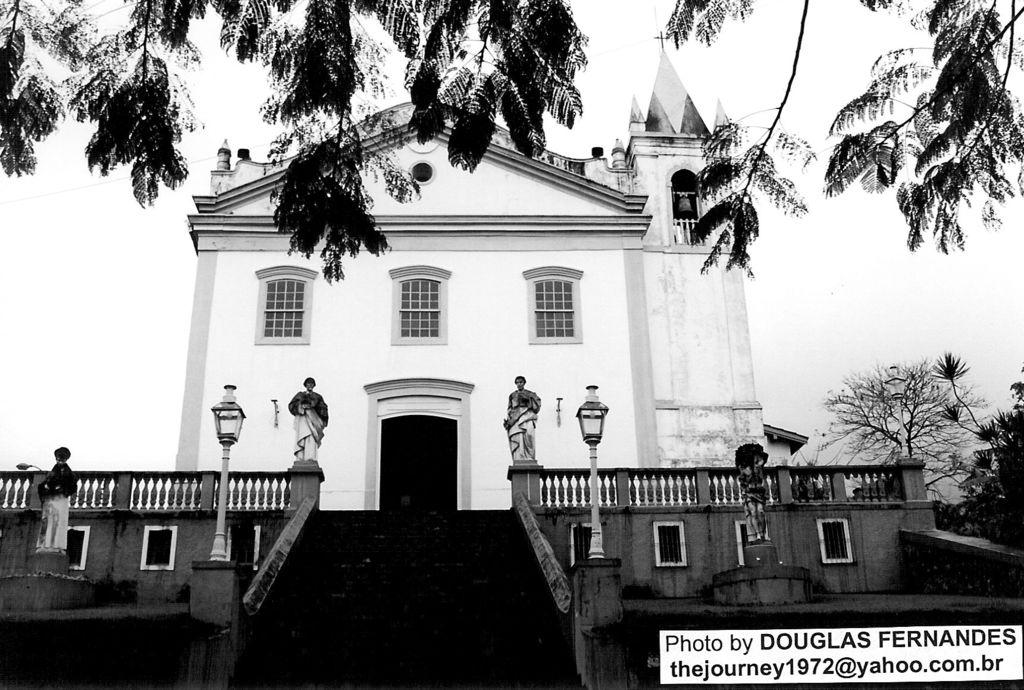What type of structure can be seen in the image? There is a building in the image. Are there any architectural features present in the image? Yes, there are stairs in the image. What other objects can be seen in the image? There are statues, a light pole attached to a pillar, trees, and a streetlight in the image. What is visible in the sky in the image? The sky is visible in the image. How many frogs are sitting on the streetlight in the image? There are no frogs present in the image, so it is not possible to determine how many might be sitting on the streetlight. 